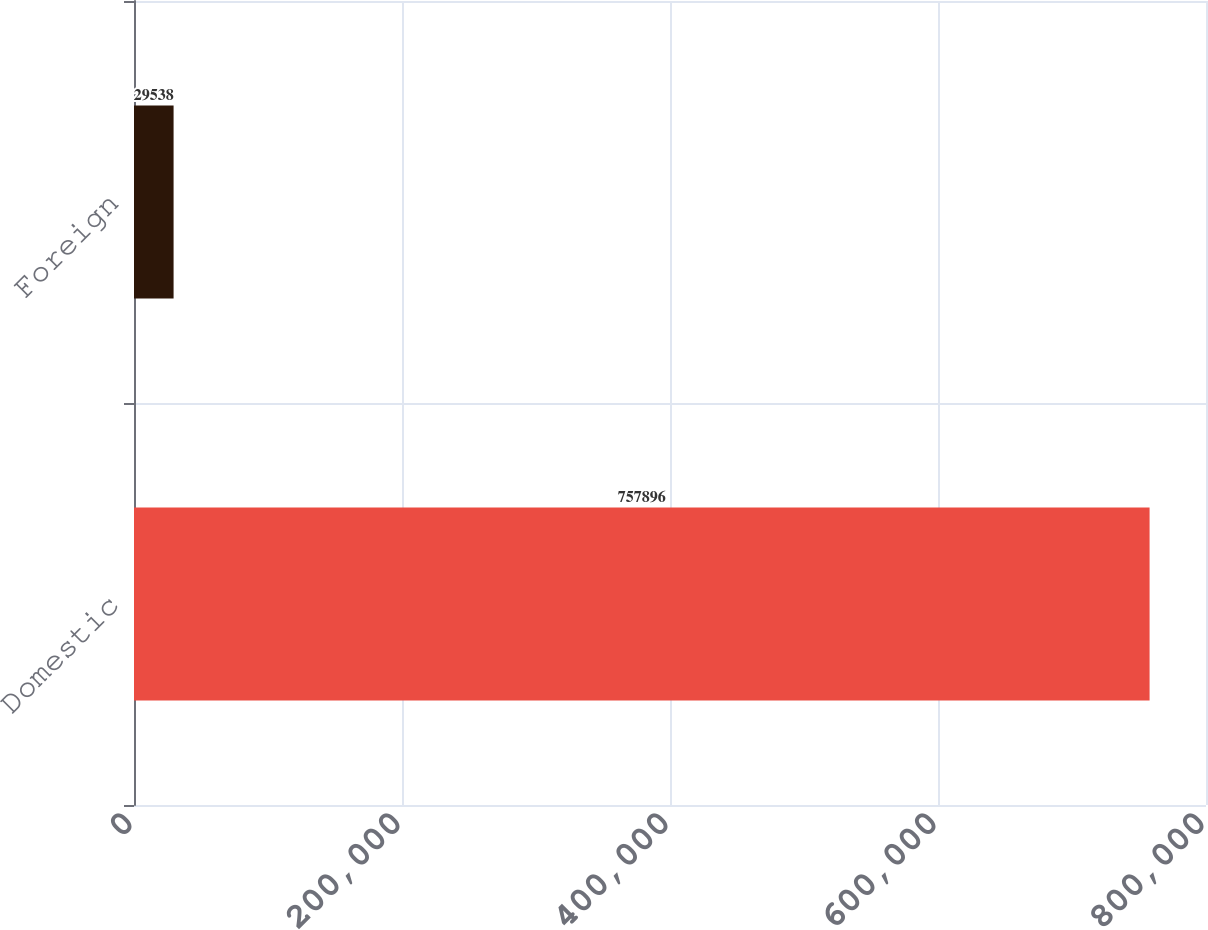Convert chart. <chart><loc_0><loc_0><loc_500><loc_500><bar_chart><fcel>Domestic<fcel>Foreign<nl><fcel>757896<fcel>29538<nl></chart> 